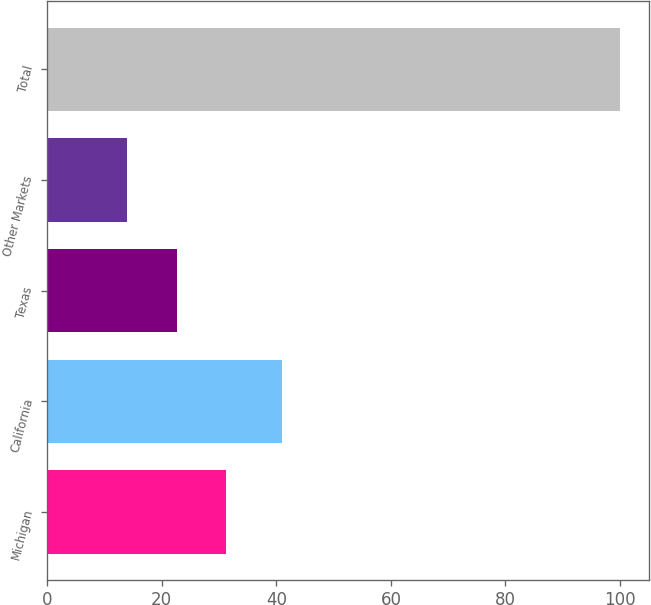<chart> <loc_0><loc_0><loc_500><loc_500><bar_chart><fcel>Michigan<fcel>California<fcel>Texas<fcel>Other Markets<fcel>Total<nl><fcel>31.2<fcel>41<fcel>22.6<fcel>14<fcel>100<nl></chart> 